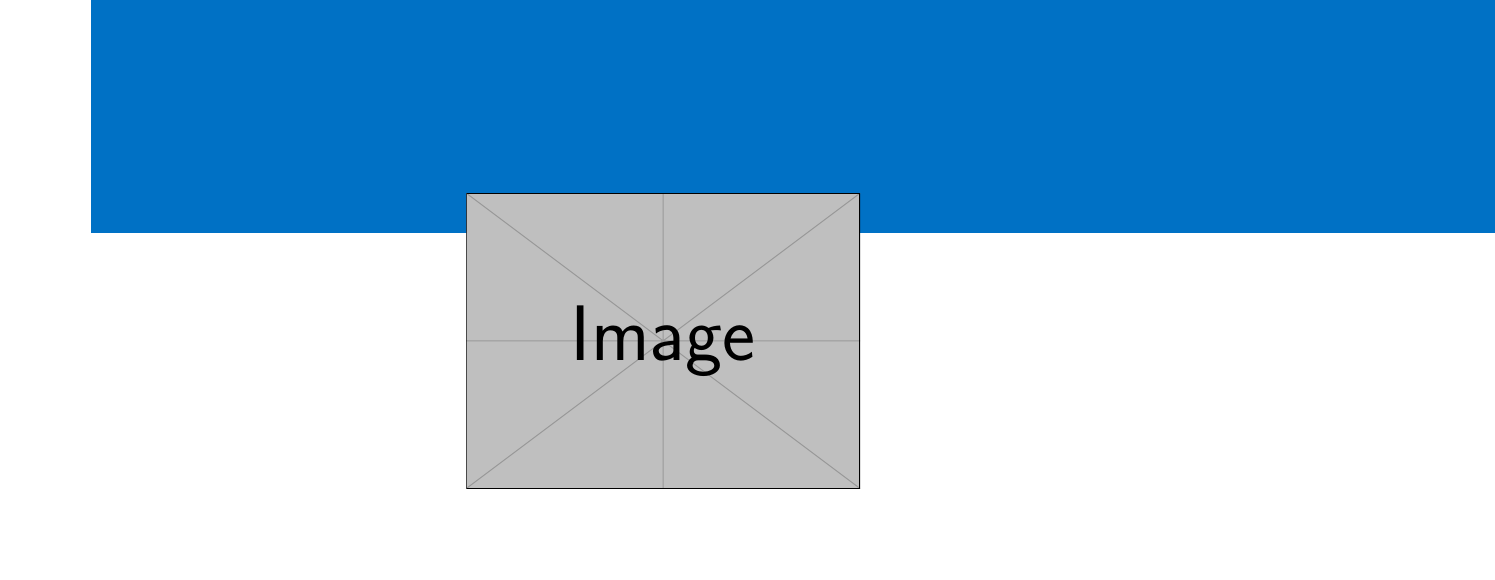What is the grant name? The grant name is explicitly mentioned in the document as "Intel Next-Gen Cooling Systems Research Grant."
Answer: Intel Next-Gen Cooling Systems Research Grant What is the funding amount? The document states the funding amount clearly: "$750,000."
Answer: $750,000 What is the duration of the grant? The duration of the grant is specified in the document as "3 years."
Answer: 3 years What is the project title? The project title is presented in the email as "Advanced Nanofluidic Cooling Systems for High-Performance Microprocessors."
Answer: Advanced Nanofluidic Cooling Systems for High-Performance Microprocessors What is the first key milestone in the project timeline? The first key milestone is noted in the document as "Initial design phase: 3 months."
Answer: Initial design phase: 3 months Which company is the industry partner? The document identifies TSMC (Taiwan Semiconductor Manufacturing Company) as the industry partner.
Answer: TSMC (Taiwan Semiconductor Manufacturing Company) How often are progress reports required? The frequency of progress reports is mentioned as "Quarterly."
Answer: Quarterly What is the end date of the project? The end date is explicitly stated in the document: "August 31, 2026."
Answer: August 31, 2026 What type of ownership is specified for intellectual property? The document states that intellectual property will have "Joint ownership between grant recipient and Intel."
Answer: Joint ownership between grant recipient and Intel 